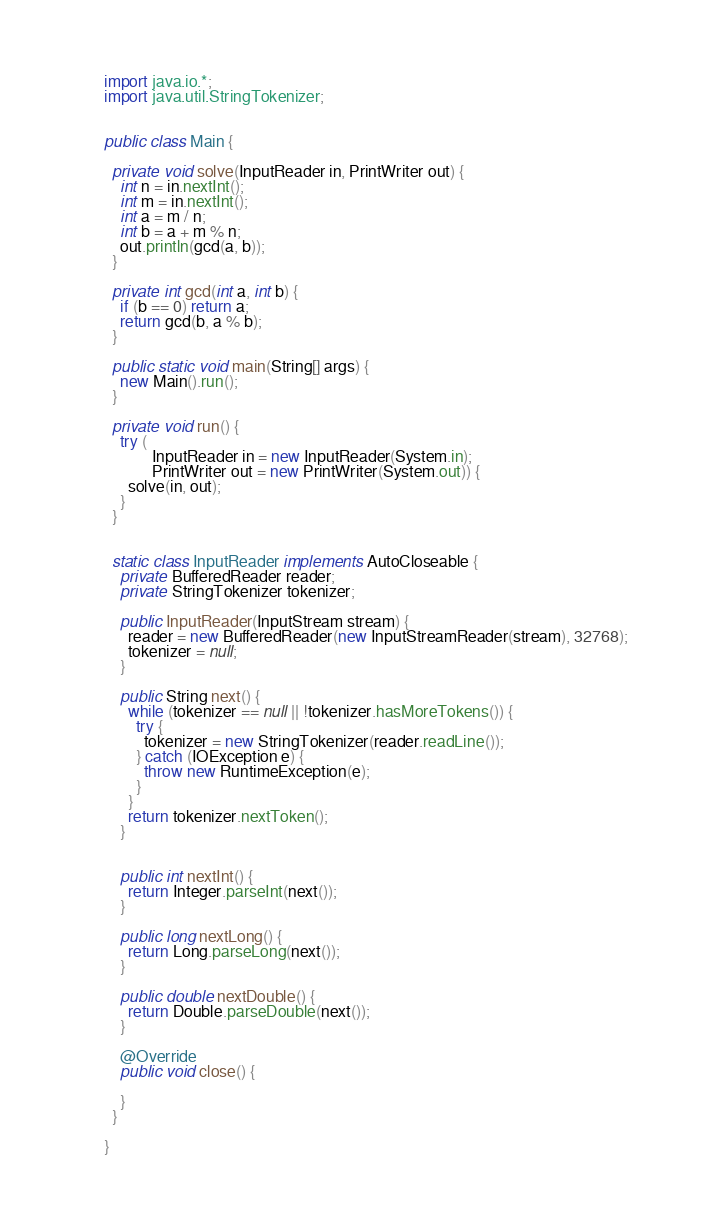<code> <loc_0><loc_0><loc_500><loc_500><_Java_>import java.io.*;
import java.util.StringTokenizer;


public class Main {

  private void solve(InputReader in, PrintWriter out) {
    int n = in.nextInt();
    int m = in.nextInt();
    int a = m / n;
    int b = a + m % n;
    out.println(gcd(a, b));
  }

  private int gcd(int a, int b) {
    if (b == 0) return a;
    return gcd(b, a % b);
  }

  public static void main(String[] args) {
    new Main().run();
  }

  private void run() {
    try (
            InputReader in = new InputReader(System.in);
            PrintWriter out = new PrintWriter(System.out)) {
      solve(in, out);
    }
  }


  static class InputReader implements AutoCloseable {
    private BufferedReader reader;
    private StringTokenizer tokenizer;

    public InputReader(InputStream stream) {
      reader = new BufferedReader(new InputStreamReader(stream), 32768);
      tokenizer = null;
    }

    public String next() {
      while (tokenizer == null || !tokenizer.hasMoreTokens()) {
        try {
          tokenizer = new StringTokenizer(reader.readLine());
        } catch (IOException e) {
          throw new RuntimeException(e);
        }
      }
      return tokenizer.nextToken();
    }


    public int nextInt() {
      return Integer.parseInt(next());
    }

    public long nextLong() {
      return Long.parseLong(next());
    }

    public double nextDouble() {
      return Double.parseDouble(next());
    }

    @Override
    public void close() {

    }
  }

}
</code> 